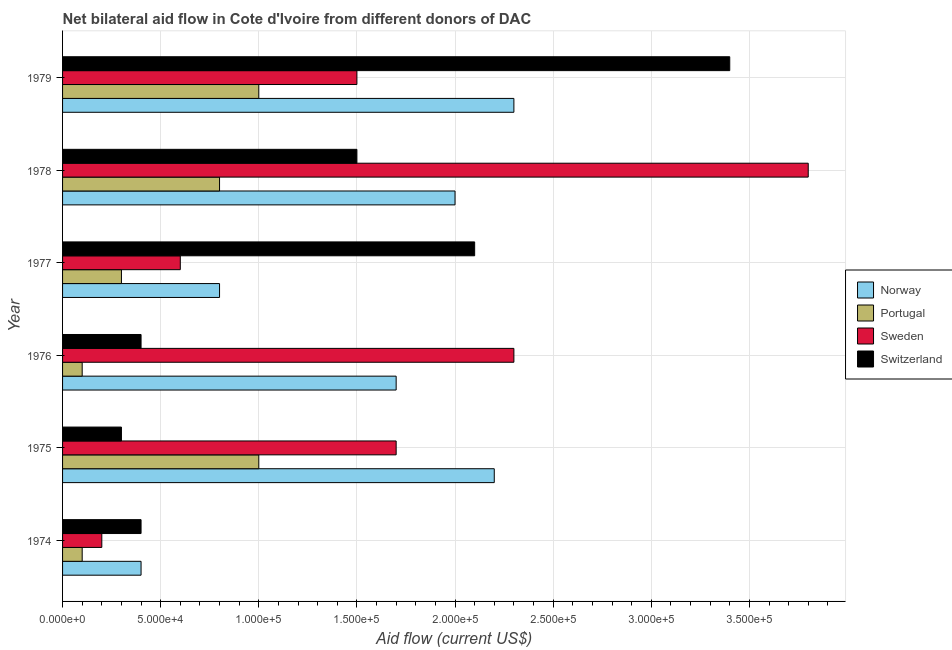Are the number of bars per tick equal to the number of legend labels?
Your response must be concise. Yes. How many bars are there on the 4th tick from the top?
Give a very brief answer. 4. How many bars are there on the 6th tick from the bottom?
Provide a short and direct response. 4. What is the label of the 1st group of bars from the top?
Keep it short and to the point. 1979. In how many cases, is the number of bars for a given year not equal to the number of legend labels?
Your answer should be very brief. 0. What is the amount of aid given by switzerland in 1977?
Offer a very short reply. 2.10e+05. Across all years, what is the maximum amount of aid given by portugal?
Ensure brevity in your answer.  1.00e+05. Across all years, what is the minimum amount of aid given by sweden?
Keep it short and to the point. 2.00e+04. In which year was the amount of aid given by sweden maximum?
Keep it short and to the point. 1978. In which year was the amount of aid given by norway minimum?
Provide a succinct answer. 1974. What is the total amount of aid given by sweden in the graph?
Provide a short and direct response. 1.01e+06. What is the difference between the amount of aid given by norway in 1976 and that in 1979?
Your answer should be very brief. -6.00e+04. What is the difference between the amount of aid given by sweden in 1979 and the amount of aid given by norway in 1978?
Give a very brief answer. -5.00e+04. What is the average amount of aid given by switzerland per year?
Offer a very short reply. 1.35e+05. In the year 1977, what is the difference between the amount of aid given by sweden and amount of aid given by switzerland?
Ensure brevity in your answer.  -1.50e+05. In how many years, is the amount of aid given by norway greater than 260000 US$?
Make the answer very short. 0. What is the ratio of the amount of aid given by sweden in 1974 to that in 1976?
Make the answer very short. 0.09. Is the amount of aid given by norway in 1976 less than that in 1978?
Your response must be concise. Yes. Is the difference between the amount of aid given by portugal in 1974 and 1977 greater than the difference between the amount of aid given by switzerland in 1974 and 1977?
Your answer should be compact. Yes. What is the difference between the highest and the lowest amount of aid given by portugal?
Provide a short and direct response. 9.00e+04. In how many years, is the amount of aid given by sweden greater than the average amount of aid given by sweden taken over all years?
Ensure brevity in your answer.  3. Is the sum of the amount of aid given by switzerland in 1974 and 1975 greater than the maximum amount of aid given by sweden across all years?
Keep it short and to the point. No. Is it the case that in every year, the sum of the amount of aid given by portugal and amount of aid given by norway is greater than the sum of amount of aid given by sweden and amount of aid given by switzerland?
Offer a terse response. No. What does the 2nd bar from the bottom in 1975 represents?
Keep it short and to the point. Portugal. Is it the case that in every year, the sum of the amount of aid given by norway and amount of aid given by portugal is greater than the amount of aid given by sweden?
Keep it short and to the point. No. How many bars are there?
Make the answer very short. 24. How many years are there in the graph?
Your response must be concise. 6. Does the graph contain grids?
Provide a short and direct response. Yes. Where does the legend appear in the graph?
Your response must be concise. Center right. How many legend labels are there?
Keep it short and to the point. 4. How are the legend labels stacked?
Your response must be concise. Vertical. What is the title of the graph?
Make the answer very short. Net bilateral aid flow in Cote d'Ivoire from different donors of DAC. What is the label or title of the Y-axis?
Ensure brevity in your answer.  Year. What is the Aid flow (current US$) of Norway in 1974?
Provide a short and direct response. 4.00e+04. What is the Aid flow (current US$) of Portugal in 1974?
Keep it short and to the point. 10000. What is the Aid flow (current US$) of Norway in 1975?
Provide a succinct answer. 2.20e+05. What is the Aid flow (current US$) in Portugal in 1975?
Your answer should be very brief. 1.00e+05. What is the Aid flow (current US$) of Switzerland in 1975?
Offer a very short reply. 3.00e+04. What is the Aid flow (current US$) of Norway in 1976?
Offer a terse response. 1.70e+05. What is the Aid flow (current US$) of Portugal in 1976?
Your answer should be very brief. 10000. What is the Aid flow (current US$) in Sweden in 1976?
Give a very brief answer. 2.30e+05. What is the Aid flow (current US$) of Switzerland in 1976?
Provide a succinct answer. 4.00e+04. What is the Aid flow (current US$) in Portugal in 1977?
Make the answer very short. 3.00e+04. What is the Aid flow (current US$) in Sweden in 1977?
Ensure brevity in your answer.  6.00e+04. What is the Aid flow (current US$) of Norway in 1978?
Keep it short and to the point. 2.00e+05. What is the Aid flow (current US$) in Portugal in 1978?
Offer a terse response. 8.00e+04. What is the Aid flow (current US$) in Sweden in 1978?
Provide a short and direct response. 3.80e+05. What is the Aid flow (current US$) of Switzerland in 1978?
Your answer should be very brief. 1.50e+05. What is the Aid flow (current US$) in Norway in 1979?
Offer a terse response. 2.30e+05. What is the Aid flow (current US$) in Sweden in 1979?
Your answer should be very brief. 1.50e+05. Across all years, what is the maximum Aid flow (current US$) in Switzerland?
Provide a succinct answer. 3.40e+05. Across all years, what is the minimum Aid flow (current US$) of Norway?
Provide a short and direct response. 4.00e+04. What is the total Aid flow (current US$) of Norway in the graph?
Keep it short and to the point. 9.40e+05. What is the total Aid flow (current US$) of Sweden in the graph?
Your response must be concise. 1.01e+06. What is the total Aid flow (current US$) of Switzerland in the graph?
Your response must be concise. 8.10e+05. What is the difference between the Aid flow (current US$) in Norway in 1974 and that in 1975?
Offer a terse response. -1.80e+05. What is the difference between the Aid flow (current US$) in Sweden in 1974 and that in 1975?
Your answer should be compact. -1.50e+05. What is the difference between the Aid flow (current US$) in Norway in 1974 and that in 1976?
Your answer should be compact. -1.30e+05. What is the difference between the Aid flow (current US$) of Sweden in 1974 and that in 1976?
Give a very brief answer. -2.10e+05. What is the difference between the Aid flow (current US$) in Sweden in 1974 and that in 1977?
Make the answer very short. -4.00e+04. What is the difference between the Aid flow (current US$) of Switzerland in 1974 and that in 1977?
Make the answer very short. -1.70e+05. What is the difference between the Aid flow (current US$) of Portugal in 1974 and that in 1978?
Provide a succinct answer. -7.00e+04. What is the difference between the Aid flow (current US$) in Sweden in 1974 and that in 1978?
Ensure brevity in your answer.  -3.60e+05. What is the difference between the Aid flow (current US$) of Switzerland in 1974 and that in 1978?
Provide a succinct answer. -1.10e+05. What is the difference between the Aid flow (current US$) in Sweden in 1974 and that in 1979?
Your answer should be very brief. -1.30e+05. What is the difference between the Aid flow (current US$) of Switzerland in 1974 and that in 1979?
Your answer should be compact. -3.00e+05. What is the difference between the Aid flow (current US$) in Portugal in 1975 and that in 1976?
Your answer should be very brief. 9.00e+04. What is the difference between the Aid flow (current US$) in Norway in 1975 and that in 1977?
Give a very brief answer. 1.40e+05. What is the difference between the Aid flow (current US$) of Portugal in 1975 and that in 1977?
Your answer should be compact. 7.00e+04. What is the difference between the Aid flow (current US$) in Sweden in 1975 and that in 1977?
Keep it short and to the point. 1.10e+05. What is the difference between the Aid flow (current US$) in Norway in 1975 and that in 1979?
Provide a short and direct response. -10000. What is the difference between the Aid flow (current US$) in Portugal in 1975 and that in 1979?
Provide a succinct answer. 0. What is the difference between the Aid flow (current US$) in Switzerland in 1975 and that in 1979?
Your answer should be compact. -3.10e+05. What is the difference between the Aid flow (current US$) in Sweden in 1976 and that in 1977?
Your answer should be compact. 1.70e+05. What is the difference between the Aid flow (current US$) of Switzerland in 1976 and that in 1978?
Your answer should be very brief. -1.10e+05. What is the difference between the Aid flow (current US$) in Norway in 1976 and that in 1979?
Keep it short and to the point. -6.00e+04. What is the difference between the Aid flow (current US$) of Portugal in 1976 and that in 1979?
Provide a short and direct response. -9.00e+04. What is the difference between the Aid flow (current US$) in Switzerland in 1976 and that in 1979?
Make the answer very short. -3.00e+05. What is the difference between the Aid flow (current US$) in Norway in 1977 and that in 1978?
Your answer should be very brief. -1.20e+05. What is the difference between the Aid flow (current US$) in Sweden in 1977 and that in 1978?
Ensure brevity in your answer.  -3.20e+05. What is the difference between the Aid flow (current US$) of Switzerland in 1977 and that in 1978?
Your response must be concise. 6.00e+04. What is the difference between the Aid flow (current US$) of Portugal in 1977 and that in 1979?
Offer a terse response. -7.00e+04. What is the difference between the Aid flow (current US$) in Norway in 1978 and that in 1979?
Your answer should be compact. -3.00e+04. What is the difference between the Aid flow (current US$) in Norway in 1974 and the Aid flow (current US$) in Sweden in 1975?
Make the answer very short. -1.30e+05. What is the difference between the Aid flow (current US$) of Norway in 1974 and the Aid flow (current US$) of Switzerland in 1975?
Keep it short and to the point. 10000. What is the difference between the Aid flow (current US$) of Portugal in 1974 and the Aid flow (current US$) of Switzerland in 1975?
Your answer should be very brief. -2.00e+04. What is the difference between the Aid flow (current US$) of Sweden in 1974 and the Aid flow (current US$) of Switzerland in 1975?
Keep it short and to the point. -10000. What is the difference between the Aid flow (current US$) in Norway in 1974 and the Aid flow (current US$) in Sweden in 1976?
Offer a very short reply. -1.90e+05. What is the difference between the Aid flow (current US$) of Norway in 1974 and the Aid flow (current US$) of Switzerland in 1976?
Provide a succinct answer. 0. What is the difference between the Aid flow (current US$) in Portugal in 1974 and the Aid flow (current US$) in Sweden in 1976?
Offer a very short reply. -2.20e+05. What is the difference between the Aid flow (current US$) of Portugal in 1974 and the Aid flow (current US$) of Switzerland in 1976?
Ensure brevity in your answer.  -3.00e+04. What is the difference between the Aid flow (current US$) of Norway in 1974 and the Aid flow (current US$) of Portugal in 1977?
Offer a terse response. 10000. What is the difference between the Aid flow (current US$) of Norway in 1974 and the Aid flow (current US$) of Sweden in 1977?
Keep it short and to the point. -2.00e+04. What is the difference between the Aid flow (current US$) in Norway in 1974 and the Aid flow (current US$) in Switzerland in 1977?
Make the answer very short. -1.70e+05. What is the difference between the Aid flow (current US$) of Portugal in 1974 and the Aid flow (current US$) of Sweden in 1977?
Your answer should be compact. -5.00e+04. What is the difference between the Aid flow (current US$) in Portugal in 1974 and the Aid flow (current US$) in Switzerland in 1977?
Keep it short and to the point. -2.00e+05. What is the difference between the Aid flow (current US$) in Norway in 1974 and the Aid flow (current US$) in Portugal in 1978?
Your answer should be very brief. -4.00e+04. What is the difference between the Aid flow (current US$) of Norway in 1974 and the Aid flow (current US$) of Sweden in 1978?
Offer a terse response. -3.40e+05. What is the difference between the Aid flow (current US$) of Norway in 1974 and the Aid flow (current US$) of Switzerland in 1978?
Provide a short and direct response. -1.10e+05. What is the difference between the Aid flow (current US$) in Portugal in 1974 and the Aid flow (current US$) in Sweden in 1978?
Your response must be concise. -3.70e+05. What is the difference between the Aid flow (current US$) in Portugal in 1974 and the Aid flow (current US$) in Switzerland in 1978?
Your answer should be compact. -1.40e+05. What is the difference between the Aid flow (current US$) of Sweden in 1974 and the Aid flow (current US$) of Switzerland in 1978?
Give a very brief answer. -1.30e+05. What is the difference between the Aid flow (current US$) in Norway in 1974 and the Aid flow (current US$) in Switzerland in 1979?
Give a very brief answer. -3.00e+05. What is the difference between the Aid flow (current US$) of Portugal in 1974 and the Aid flow (current US$) of Sweden in 1979?
Make the answer very short. -1.40e+05. What is the difference between the Aid flow (current US$) of Portugal in 1974 and the Aid flow (current US$) of Switzerland in 1979?
Give a very brief answer. -3.30e+05. What is the difference between the Aid flow (current US$) of Sweden in 1974 and the Aid flow (current US$) of Switzerland in 1979?
Offer a very short reply. -3.20e+05. What is the difference between the Aid flow (current US$) of Norway in 1975 and the Aid flow (current US$) of Portugal in 1976?
Provide a succinct answer. 2.10e+05. What is the difference between the Aid flow (current US$) in Norway in 1975 and the Aid flow (current US$) in Switzerland in 1976?
Provide a short and direct response. 1.80e+05. What is the difference between the Aid flow (current US$) of Portugal in 1975 and the Aid flow (current US$) of Sweden in 1976?
Offer a very short reply. -1.30e+05. What is the difference between the Aid flow (current US$) of Portugal in 1975 and the Aid flow (current US$) of Switzerland in 1976?
Make the answer very short. 6.00e+04. What is the difference between the Aid flow (current US$) of Sweden in 1975 and the Aid flow (current US$) of Switzerland in 1976?
Your answer should be compact. 1.30e+05. What is the difference between the Aid flow (current US$) of Norway in 1975 and the Aid flow (current US$) of Portugal in 1977?
Offer a very short reply. 1.90e+05. What is the difference between the Aid flow (current US$) in Portugal in 1975 and the Aid flow (current US$) in Sweden in 1977?
Provide a short and direct response. 4.00e+04. What is the difference between the Aid flow (current US$) of Portugal in 1975 and the Aid flow (current US$) of Switzerland in 1977?
Keep it short and to the point. -1.10e+05. What is the difference between the Aid flow (current US$) in Norway in 1975 and the Aid flow (current US$) in Portugal in 1978?
Offer a very short reply. 1.40e+05. What is the difference between the Aid flow (current US$) of Portugal in 1975 and the Aid flow (current US$) of Sweden in 1978?
Provide a succinct answer. -2.80e+05. What is the difference between the Aid flow (current US$) in Portugal in 1975 and the Aid flow (current US$) in Switzerland in 1978?
Give a very brief answer. -5.00e+04. What is the difference between the Aid flow (current US$) in Norway in 1975 and the Aid flow (current US$) in Sweden in 1979?
Give a very brief answer. 7.00e+04. What is the difference between the Aid flow (current US$) in Portugal in 1975 and the Aid flow (current US$) in Switzerland in 1979?
Give a very brief answer. -2.40e+05. What is the difference between the Aid flow (current US$) in Portugal in 1976 and the Aid flow (current US$) in Sweden in 1977?
Offer a very short reply. -5.00e+04. What is the difference between the Aid flow (current US$) of Norway in 1976 and the Aid flow (current US$) of Switzerland in 1978?
Your answer should be compact. 2.00e+04. What is the difference between the Aid flow (current US$) in Portugal in 1976 and the Aid flow (current US$) in Sweden in 1978?
Your answer should be very brief. -3.70e+05. What is the difference between the Aid flow (current US$) in Portugal in 1976 and the Aid flow (current US$) in Switzerland in 1978?
Make the answer very short. -1.40e+05. What is the difference between the Aid flow (current US$) in Norway in 1976 and the Aid flow (current US$) in Portugal in 1979?
Offer a very short reply. 7.00e+04. What is the difference between the Aid flow (current US$) of Norway in 1976 and the Aid flow (current US$) of Switzerland in 1979?
Your answer should be compact. -1.70e+05. What is the difference between the Aid flow (current US$) in Portugal in 1976 and the Aid flow (current US$) in Sweden in 1979?
Ensure brevity in your answer.  -1.40e+05. What is the difference between the Aid flow (current US$) of Portugal in 1976 and the Aid flow (current US$) of Switzerland in 1979?
Offer a terse response. -3.30e+05. What is the difference between the Aid flow (current US$) of Norway in 1977 and the Aid flow (current US$) of Portugal in 1978?
Provide a short and direct response. 0. What is the difference between the Aid flow (current US$) in Norway in 1977 and the Aid flow (current US$) in Sweden in 1978?
Ensure brevity in your answer.  -3.00e+05. What is the difference between the Aid flow (current US$) of Norway in 1977 and the Aid flow (current US$) of Switzerland in 1978?
Provide a succinct answer. -7.00e+04. What is the difference between the Aid flow (current US$) of Portugal in 1977 and the Aid flow (current US$) of Sweden in 1978?
Ensure brevity in your answer.  -3.50e+05. What is the difference between the Aid flow (current US$) in Portugal in 1977 and the Aid flow (current US$) in Switzerland in 1978?
Your response must be concise. -1.20e+05. What is the difference between the Aid flow (current US$) in Sweden in 1977 and the Aid flow (current US$) in Switzerland in 1978?
Provide a short and direct response. -9.00e+04. What is the difference between the Aid flow (current US$) of Norway in 1977 and the Aid flow (current US$) of Sweden in 1979?
Your answer should be compact. -7.00e+04. What is the difference between the Aid flow (current US$) in Norway in 1977 and the Aid flow (current US$) in Switzerland in 1979?
Make the answer very short. -2.60e+05. What is the difference between the Aid flow (current US$) in Portugal in 1977 and the Aid flow (current US$) in Switzerland in 1979?
Offer a very short reply. -3.10e+05. What is the difference between the Aid flow (current US$) in Sweden in 1977 and the Aid flow (current US$) in Switzerland in 1979?
Make the answer very short. -2.80e+05. What is the difference between the Aid flow (current US$) of Norway in 1978 and the Aid flow (current US$) of Switzerland in 1979?
Provide a short and direct response. -1.40e+05. What is the difference between the Aid flow (current US$) in Portugal in 1978 and the Aid flow (current US$) in Sweden in 1979?
Make the answer very short. -7.00e+04. What is the average Aid flow (current US$) of Norway per year?
Make the answer very short. 1.57e+05. What is the average Aid flow (current US$) of Portugal per year?
Your response must be concise. 5.50e+04. What is the average Aid flow (current US$) in Sweden per year?
Your answer should be very brief. 1.68e+05. What is the average Aid flow (current US$) in Switzerland per year?
Your answer should be very brief. 1.35e+05. In the year 1975, what is the difference between the Aid flow (current US$) of Portugal and Aid flow (current US$) of Switzerland?
Offer a terse response. 7.00e+04. In the year 1976, what is the difference between the Aid flow (current US$) in Norway and Aid flow (current US$) in Portugal?
Make the answer very short. 1.60e+05. In the year 1976, what is the difference between the Aid flow (current US$) of Norway and Aid flow (current US$) of Sweden?
Provide a short and direct response. -6.00e+04. In the year 1976, what is the difference between the Aid flow (current US$) in Norway and Aid flow (current US$) in Switzerland?
Offer a very short reply. 1.30e+05. In the year 1976, what is the difference between the Aid flow (current US$) in Portugal and Aid flow (current US$) in Sweden?
Your response must be concise. -2.20e+05. In the year 1977, what is the difference between the Aid flow (current US$) of Norway and Aid flow (current US$) of Sweden?
Make the answer very short. 2.00e+04. In the year 1977, what is the difference between the Aid flow (current US$) in Norway and Aid flow (current US$) in Switzerland?
Your answer should be compact. -1.30e+05. In the year 1977, what is the difference between the Aid flow (current US$) in Portugal and Aid flow (current US$) in Sweden?
Keep it short and to the point. -3.00e+04. In the year 1978, what is the difference between the Aid flow (current US$) of Norway and Aid flow (current US$) of Sweden?
Offer a terse response. -1.80e+05. In the year 1978, what is the difference between the Aid flow (current US$) of Portugal and Aid flow (current US$) of Sweden?
Offer a very short reply. -3.00e+05. In the year 1978, what is the difference between the Aid flow (current US$) in Sweden and Aid flow (current US$) in Switzerland?
Offer a very short reply. 2.30e+05. In the year 1979, what is the difference between the Aid flow (current US$) of Norway and Aid flow (current US$) of Portugal?
Give a very brief answer. 1.30e+05. In the year 1979, what is the difference between the Aid flow (current US$) of Norway and Aid flow (current US$) of Switzerland?
Provide a succinct answer. -1.10e+05. What is the ratio of the Aid flow (current US$) in Norway in 1974 to that in 1975?
Keep it short and to the point. 0.18. What is the ratio of the Aid flow (current US$) of Sweden in 1974 to that in 1975?
Offer a very short reply. 0.12. What is the ratio of the Aid flow (current US$) of Norway in 1974 to that in 1976?
Keep it short and to the point. 0.24. What is the ratio of the Aid flow (current US$) of Sweden in 1974 to that in 1976?
Ensure brevity in your answer.  0.09. What is the ratio of the Aid flow (current US$) of Norway in 1974 to that in 1977?
Provide a short and direct response. 0.5. What is the ratio of the Aid flow (current US$) of Portugal in 1974 to that in 1977?
Offer a very short reply. 0.33. What is the ratio of the Aid flow (current US$) of Sweden in 1974 to that in 1977?
Make the answer very short. 0.33. What is the ratio of the Aid flow (current US$) in Switzerland in 1974 to that in 1977?
Keep it short and to the point. 0.19. What is the ratio of the Aid flow (current US$) in Portugal in 1974 to that in 1978?
Your answer should be compact. 0.12. What is the ratio of the Aid flow (current US$) of Sweden in 1974 to that in 1978?
Ensure brevity in your answer.  0.05. What is the ratio of the Aid flow (current US$) of Switzerland in 1974 to that in 1978?
Keep it short and to the point. 0.27. What is the ratio of the Aid flow (current US$) of Norway in 1974 to that in 1979?
Ensure brevity in your answer.  0.17. What is the ratio of the Aid flow (current US$) of Portugal in 1974 to that in 1979?
Make the answer very short. 0.1. What is the ratio of the Aid flow (current US$) of Sweden in 1974 to that in 1979?
Your answer should be very brief. 0.13. What is the ratio of the Aid flow (current US$) in Switzerland in 1974 to that in 1979?
Keep it short and to the point. 0.12. What is the ratio of the Aid flow (current US$) in Norway in 1975 to that in 1976?
Provide a succinct answer. 1.29. What is the ratio of the Aid flow (current US$) in Portugal in 1975 to that in 1976?
Your answer should be compact. 10. What is the ratio of the Aid flow (current US$) in Sweden in 1975 to that in 1976?
Give a very brief answer. 0.74. What is the ratio of the Aid flow (current US$) in Switzerland in 1975 to that in 1976?
Your answer should be compact. 0.75. What is the ratio of the Aid flow (current US$) of Norway in 1975 to that in 1977?
Ensure brevity in your answer.  2.75. What is the ratio of the Aid flow (current US$) of Portugal in 1975 to that in 1977?
Offer a very short reply. 3.33. What is the ratio of the Aid flow (current US$) of Sweden in 1975 to that in 1977?
Provide a short and direct response. 2.83. What is the ratio of the Aid flow (current US$) in Switzerland in 1975 to that in 1977?
Your answer should be very brief. 0.14. What is the ratio of the Aid flow (current US$) of Norway in 1975 to that in 1978?
Keep it short and to the point. 1.1. What is the ratio of the Aid flow (current US$) in Sweden in 1975 to that in 1978?
Your answer should be very brief. 0.45. What is the ratio of the Aid flow (current US$) in Norway in 1975 to that in 1979?
Give a very brief answer. 0.96. What is the ratio of the Aid flow (current US$) in Sweden in 1975 to that in 1979?
Your answer should be compact. 1.13. What is the ratio of the Aid flow (current US$) in Switzerland in 1975 to that in 1979?
Ensure brevity in your answer.  0.09. What is the ratio of the Aid flow (current US$) in Norway in 1976 to that in 1977?
Your answer should be very brief. 2.12. What is the ratio of the Aid flow (current US$) in Sweden in 1976 to that in 1977?
Your answer should be very brief. 3.83. What is the ratio of the Aid flow (current US$) of Switzerland in 1976 to that in 1977?
Your response must be concise. 0.19. What is the ratio of the Aid flow (current US$) of Norway in 1976 to that in 1978?
Provide a succinct answer. 0.85. What is the ratio of the Aid flow (current US$) in Portugal in 1976 to that in 1978?
Ensure brevity in your answer.  0.12. What is the ratio of the Aid flow (current US$) of Sweden in 1976 to that in 1978?
Offer a terse response. 0.61. What is the ratio of the Aid flow (current US$) in Switzerland in 1976 to that in 1978?
Offer a very short reply. 0.27. What is the ratio of the Aid flow (current US$) in Norway in 1976 to that in 1979?
Your answer should be very brief. 0.74. What is the ratio of the Aid flow (current US$) in Sweden in 1976 to that in 1979?
Your answer should be compact. 1.53. What is the ratio of the Aid flow (current US$) in Switzerland in 1976 to that in 1979?
Provide a succinct answer. 0.12. What is the ratio of the Aid flow (current US$) in Portugal in 1977 to that in 1978?
Keep it short and to the point. 0.38. What is the ratio of the Aid flow (current US$) in Sweden in 1977 to that in 1978?
Ensure brevity in your answer.  0.16. What is the ratio of the Aid flow (current US$) of Switzerland in 1977 to that in 1978?
Ensure brevity in your answer.  1.4. What is the ratio of the Aid flow (current US$) of Norway in 1977 to that in 1979?
Ensure brevity in your answer.  0.35. What is the ratio of the Aid flow (current US$) of Portugal in 1977 to that in 1979?
Ensure brevity in your answer.  0.3. What is the ratio of the Aid flow (current US$) in Switzerland in 1977 to that in 1979?
Offer a terse response. 0.62. What is the ratio of the Aid flow (current US$) in Norway in 1978 to that in 1979?
Ensure brevity in your answer.  0.87. What is the ratio of the Aid flow (current US$) in Sweden in 1978 to that in 1979?
Keep it short and to the point. 2.53. What is the ratio of the Aid flow (current US$) of Switzerland in 1978 to that in 1979?
Ensure brevity in your answer.  0.44. What is the difference between the highest and the second highest Aid flow (current US$) of Norway?
Your answer should be compact. 10000. What is the difference between the highest and the second highest Aid flow (current US$) of Portugal?
Make the answer very short. 0. What is the difference between the highest and the second highest Aid flow (current US$) in Sweden?
Provide a short and direct response. 1.50e+05. What is the difference between the highest and the lowest Aid flow (current US$) in Portugal?
Your response must be concise. 9.00e+04. What is the difference between the highest and the lowest Aid flow (current US$) in Sweden?
Your answer should be compact. 3.60e+05. 